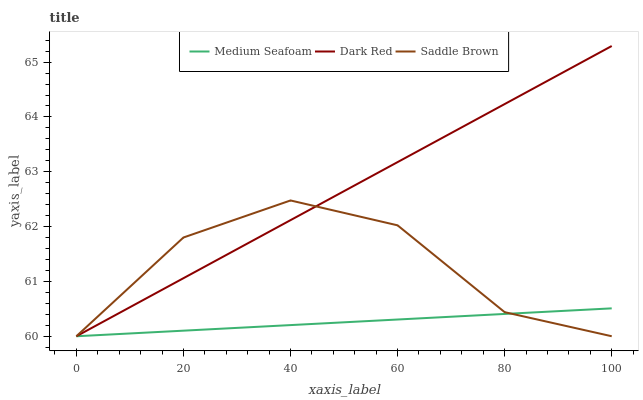Does Medium Seafoam have the minimum area under the curve?
Answer yes or no. Yes. Does Dark Red have the maximum area under the curve?
Answer yes or no. Yes. Does Saddle Brown have the minimum area under the curve?
Answer yes or no. No. Does Saddle Brown have the maximum area under the curve?
Answer yes or no. No. Is Medium Seafoam the smoothest?
Answer yes or no. Yes. Is Saddle Brown the roughest?
Answer yes or no. Yes. Is Saddle Brown the smoothest?
Answer yes or no. No. Is Medium Seafoam the roughest?
Answer yes or no. No. Does Dark Red have the lowest value?
Answer yes or no. Yes. Does Dark Red have the highest value?
Answer yes or no. Yes. Does Saddle Brown have the highest value?
Answer yes or no. No. Does Dark Red intersect Saddle Brown?
Answer yes or no. Yes. Is Dark Red less than Saddle Brown?
Answer yes or no. No. Is Dark Red greater than Saddle Brown?
Answer yes or no. No. 